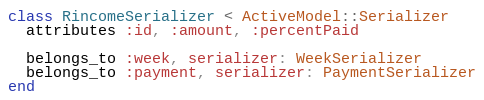Convert code to text. <code><loc_0><loc_0><loc_500><loc_500><_Ruby_>class RincomeSerializer < ActiveModel::Serializer
  attributes :id, :amount, :percentPaid

  belongs_to :week, serializer: WeekSerializer
  belongs_to :payment, serializer: PaymentSerializer
end
</code> 